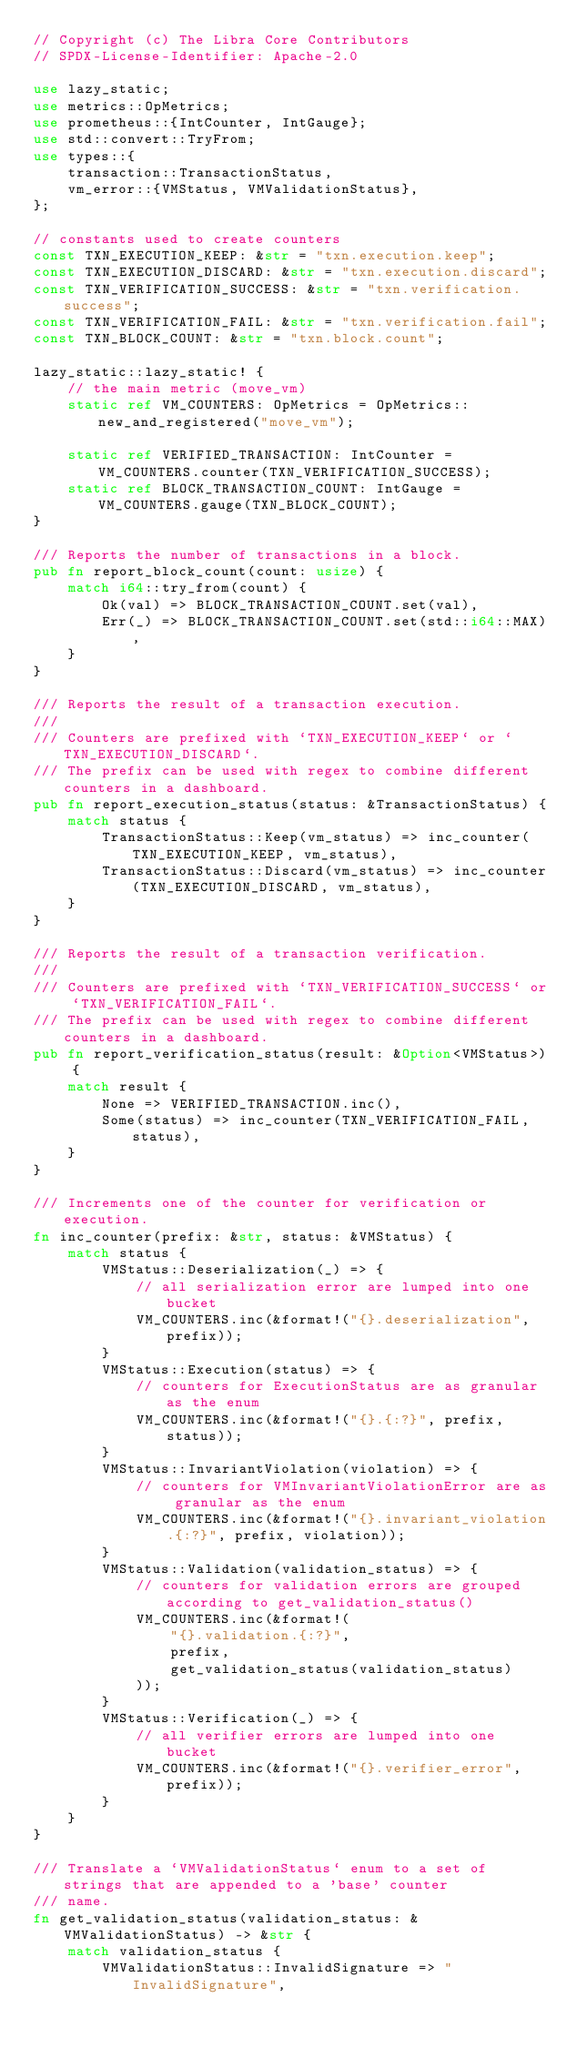<code> <loc_0><loc_0><loc_500><loc_500><_Rust_>// Copyright (c) The Libra Core Contributors
// SPDX-License-Identifier: Apache-2.0

use lazy_static;
use metrics::OpMetrics;
use prometheus::{IntCounter, IntGauge};
use std::convert::TryFrom;
use types::{
    transaction::TransactionStatus,
    vm_error::{VMStatus, VMValidationStatus},
};

// constants used to create counters
const TXN_EXECUTION_KEEP: &str = "txn.execution.keep";
const TXN_EXECUTION_DISCARD: &str = "txn.execution.discard";
const TXN_VERIFICATION_SUCCESS: &str = "txn.verification.success";
const TXN_VERIFICATION_FAIL: &str = "txn.verification.fail";
const TXN_BLOCK_COUNT: &str = "txn.block.count";

lazy_static::lazy_static! {
    // the main metric (move_vm)
    static ref VM_COUNTERS: OpMetrics = OpMetrics::new_and_registered("move_vm");

    static ref VERIFIED_TRANSACTION: IntCounter = VM_COUNTERS.counter(TXN_VERIFICATION_SUCCESS);
    static ref BLOCK_TRANSACTION_COUNT: IntGauge = VM_COUNTERS.gauge(TXN_BLOCK_COUNT);
}

/// Reports the number of transactions in a block.
pub fn report_block_count(count: usize) {
    match i64::try_from(count) {
        Ok(val) => BLOCK_TRANSACTION_COUNT.set(val),
        Err(_) => BLOCK_TRANSACTION_COUNT.set(std::i64::MAX),
    }
}

/// Reports the result of a transaction execution.
///
/// Counters are prefixed with `TXN_EXECUTION_KEEP` or `TXN_EXECUTION_DISCARD`.
/// The prefix can be used with regex to combine different counters in a dashboard.
pub fn report_execution_status(status: &TransactionStatus) {
    match status {
        TransactionStatus::Keep(vm_status) => inc_counter(TXN_EXECUTION_KEEP, vm_status),
        TransactionStatus::Discard(vm_status) => inc_counter(TXN_EXECUTION_DISCARD, vm_status),
    }
}

/// Reports the result of a transaction verification.
///
/// Counters are prefixed with `TXN_VERIFICATION_SUCCESS` or `TXN_VERIFICATION_FAIL`.
/// The prefix can be used with regex to combine different counters in a dashboard.
pub fn report_verification_status(result: &Option<VMStatus>) {
    match result {
        None => VERIFIED_TRANSACTION.inc(),
        Some(status) => inc_counter(TXN_VERIFICATION_FAIL, status),
    }
}

/// Increments one of the counter for verification or execution.
fn inc_counter(prefix: &str, status: &VMStatus) {
    match status {
        VMStatus::Deserialization(_) => {
            // all serialization error are lumped into one bucket
            VM_COUNTERS.inc(&format!("{}.deserialization", prefix));
        }
        VMStatus::Execution(status) => {
            // counters for ExecutionStatus are as granular as the enum
            VM_COUNTERS.inc(&format!("{}.{:?}", prefix, status));
        }
        VMStatus::InvariantViolation(violation) => {
            // counters for VMInvariantViolationError are as granular as the enum
            VM_COUNTERS.inc(&format!("{}.invariant_violation.{:?}", prefix, violation));
        }
        VMStatus::Validation(validation_status) => {
            // counters for validation errors are grouped according to get_validation_status()
            VM_COUNTERS.inc(&format!(
                "{}.validation.{:?}",
                prefix,
                get_validation_status(validation_status)
            ));
        }
        VMStatus::Verification(_) => {
            // all verifier errors are lumped into one bucket
            VM_COUNTERS.inc(&format!("{}.verifier_error", prefix));
        }
    }
}

/// Translate a `VMValidationStatus` enum to a set of strings that are appended to a 'base' counter
/// name.
fn get_validation_status(validation_status: &VMValidationStatus) -> &str {
    match validation_status {
        VMValidationStatus::InvalidSignature => "InvalidSignature",</code> 